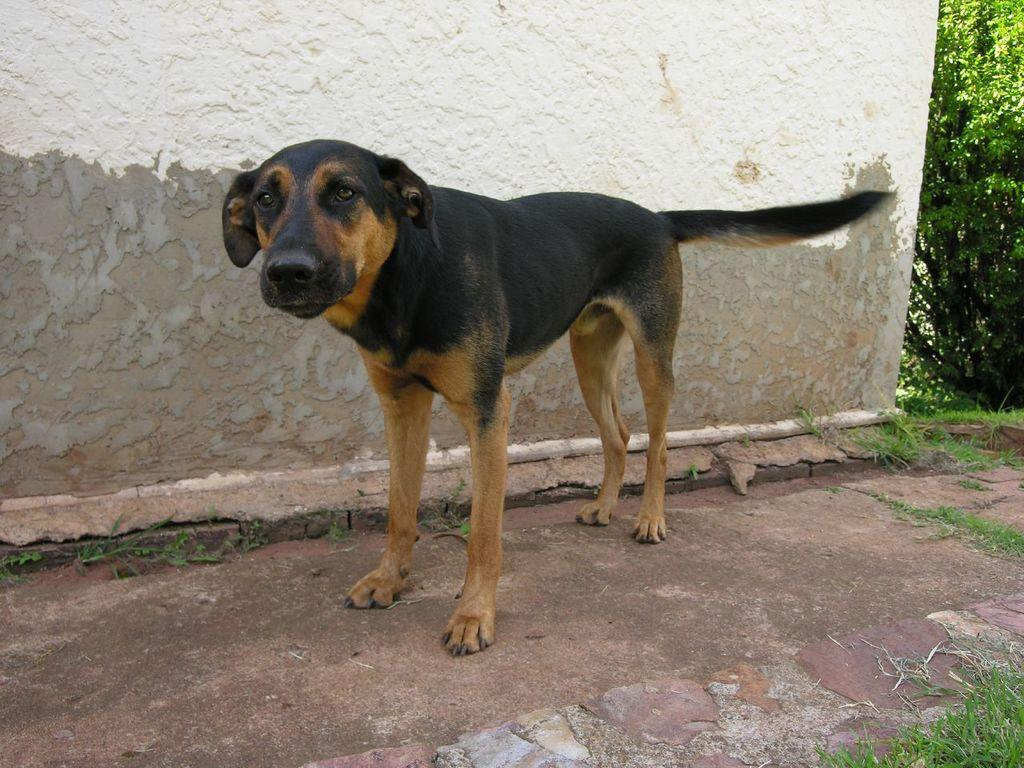What animal can be seen in the image? There is a dog in the image. Where is the dog positioned in relation to the wall? The dog is standing in front of a wall. What type of vegetation is visible beside the wall? There is grass and plants beside the wall in the image. What type of beam is holding up the trees in the image? There are no trees or beams present in the image. How does the dog's breath affect the plants in the image? The dog's breath does not affect the plants in the image, as there is no interaction between the dog and the plants. 